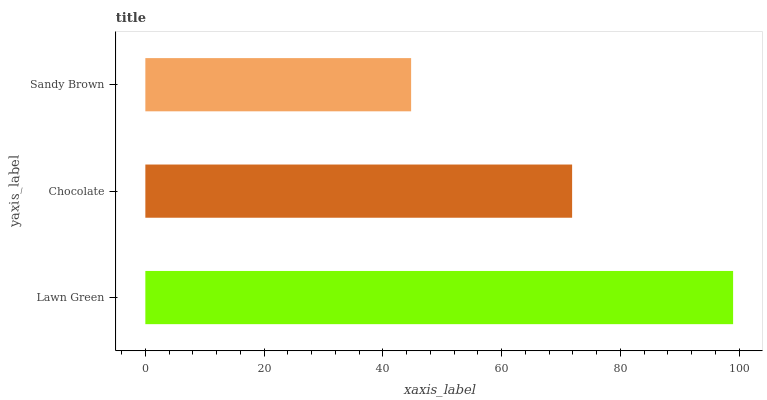Is Sandy Brown the minimum?
Answer yes or no. Yes. Is Lawn Green the maximum?
Answer yes or no. Yes. Is Chocolate the minimum?
Answer yes or no. No. Is Chocolate the maximum?
Answer yes or no. No. Is Lawn Green greater than Chocolate?
Answer yes or no. Yes. Is Chocolate less than Lawn Green?
Answer yes or no. Yes. Is Chocolate greater than Lawn Green?
Answer yes or no. No. Is Lawn Green less than Chocolate?
Answer yes or no. No. Is Chocolate the high median?
Answer yes or no. Yes. Is Chocolate the low median?
Answer yes or no. Yes. Is Lawn Green the high median?
Answer yes or no. No. Is Sandy Brown the low median?
Answer yes or no. No. 